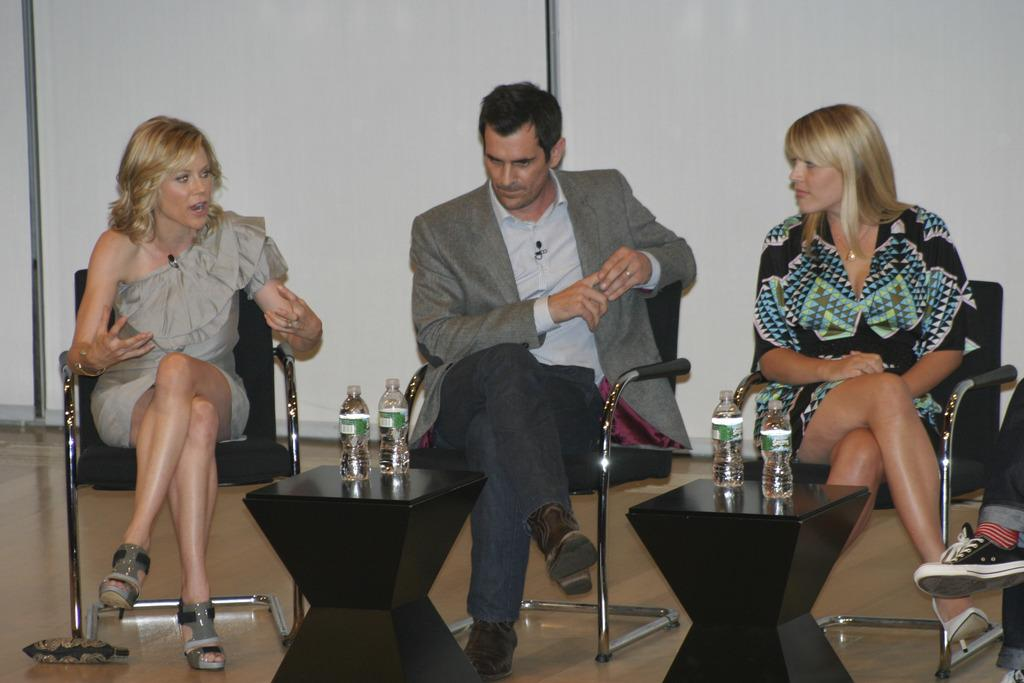How many people are in the image? There are three people in the image. What are the people doing in the image? The people are sitting on a chair. What objects are in front of the people? There are black tables in front of the people. What can be seen on top of the tables? There are two water bottles on top of the tables. Can you tell me how many buns are on the chair in the image? There are no buns present in the image; the people are sitting on a chair. What type of wind can be felt coming from the stranger in the image? There is no stranger present in the image, and therefore no wind can be felt coming from them. 